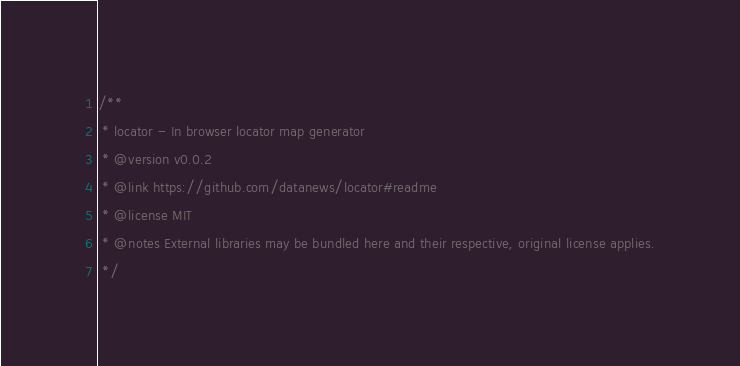<code> <loc_0><loc_0><loc_500><loc_500><_CSS_>/**
 * locator - In browser locator map generator
 * @version v0.0.2
 * @link https://github.com/datanews/locator#readme
 * @license MIT
 * @notes External libraries may be bundled here and their respective, original license applies.
 */</code> 